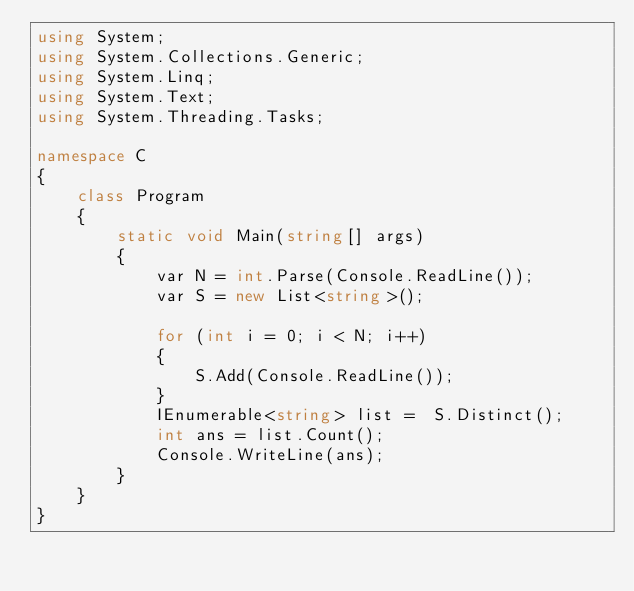<code> <loc_0><loc_0><loc_500><loc_500><_C#_>using System;
using System.Collections.Generic;
using System.Linq;
using System.Text;
using System.Threading.Tasks;

namespace C
{
    class Program
    {
        static void Main(string[] args)
        {
            var N = int.Parse(Console.ReadLine());
            var S = new List<string>();

            for (int i = 0; i < N; i++)
            {
                S.Add(Console.ReadLine());
            }
            IEnumerable<string> list =  S.Distinct();
            int ans = list.Count();
            Console.WriteLine(ans);
        }
    }
}</code> 